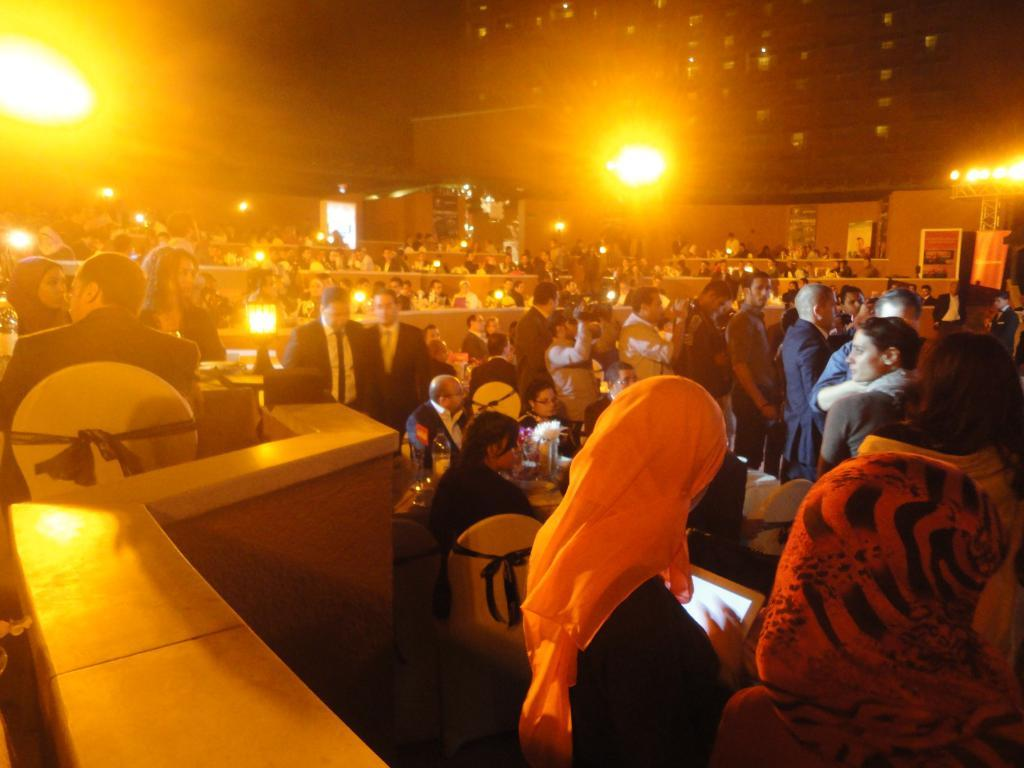How many people are in the image? There is a group of people in the image. Where are the people in the image located? The group of people is sitting in the right corner, and the remaining people are also sitting. What can be seen on either side of the people? There are yellow lights on either side of the people. What type of fruit is being passed around among the people in the image? There is no fruit present in the image; the people are sitting and there are yellow lights on either side of them. 